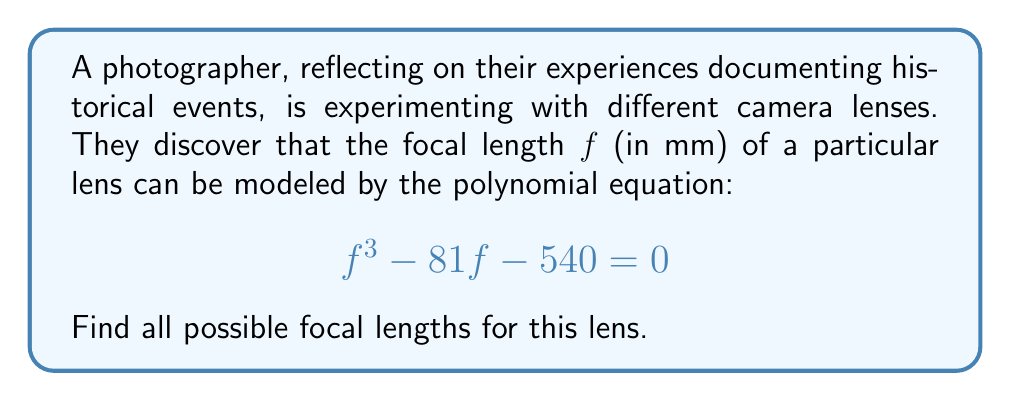Help me with this question. Let's approach this step-by-step:

1) First, we recognize this as a cubic equation in the form $x^3 + px + q = 0$, where $x = f$, $p = -81$, and $q = -540$.

2) For cubic equations of this form, we can use Cardano's formula. Let's define:

   $u = \sqrt[3]{-\frac{q}{2} + \sqrt{\frac{q^2}{4} + \frac{p^3}{27}}}$
   $v = \sqrt[3]{-\frac{q}{2} - \sqrt{\frac{q^2}{4} + \frac{p^3}{27}}}$

3) Substituting our values:

   $u = \sqrt[3]{270 + \sqrt{72900 + (-81)^3/27}} = \sqrt[3]{270 + \sqrt{72900 - 19683}} = \sqrt[3]{270 + \sqrt{53217}} = 9$

   $v = \sqrt[3]{270 - \sqrt{53217}} = 3$

4) The solutions are given by $x = u + v$, $x = -\frac{u+v}{2} + i\frac{\sqrt{3}}{2}(u-v)$, and $x = -\frac{u+v}{2} - i\frac{\sqrt{3}}{2}(u-v)$

5) Calculating:
   
   $x_1 = u + v = 9 + 3 = 12$
   
   $x_2 = -\frac{12}{2} + i\frac{\sqrt{3}}{2}(6) = -6 + 3i\sqrt{3}$
   
   $x_3 = -\frac{12}{2} - i\frac{\sqrt{3}}{2}(6) = -6 - 3i\sqrt{3}$

6) Since focal length must be real and positive, we discard the complex solutions.

Therefore, the only valid focal length is 12 mm.
Answer: 12 mm 